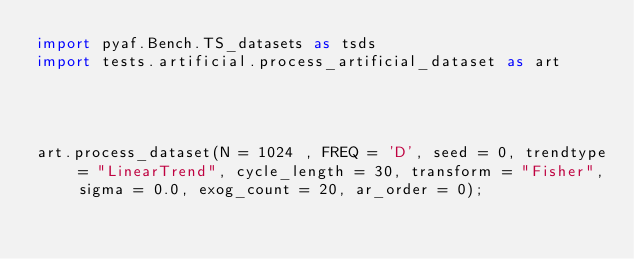<code> <loc_0><loc_0><loc_500><loc_500><_Python_>import pyaf.Bench.TS_datasets as tsds
import tests.artificial.process_artificial_dataset as art




art.process_dataset(N = 1024 , FREQ = 'D', seed = 0, trendtype = "LinearTrend", cycle_length = 30, transform = "Fisher", sigma = 0.0, exog_count = 20, ar_order = 0);</code> 